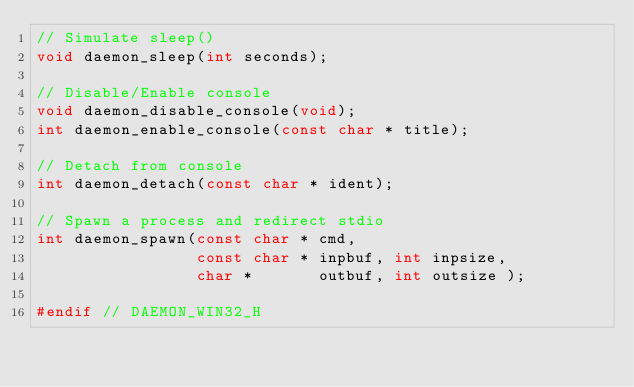<code> <loc_0><loc_0><loc_500><loc_500><_C_>// Simulate sleep()
void daemon_sleep(int seconds);

// Disable/Enable console
void daemon_disable_console(void);
int daemon_enable_console(const char * title);

// Detach from console
int daemon_detach(const char * ident);

// Spawn a process and redirect stdio
int daemon_spawn(const char * cmd,
                 const char * inpbuf, int inpsize,
                 char *       outbuf, int outsize );

#endif // DAEMON_WIN32_H
</code> 